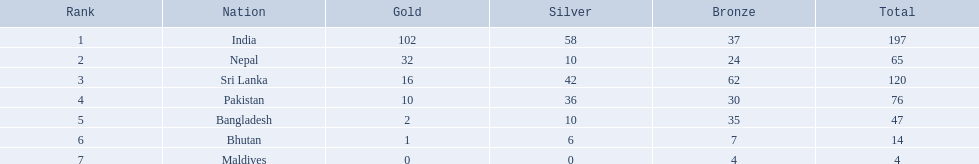Which nations participated in the 1999 south asian games? India, Nepal, Sri Lanka, Pakistan, Bangladesh, Bhutan, Maldives. Among them, which one secured 32 gold medals? Nepal. 